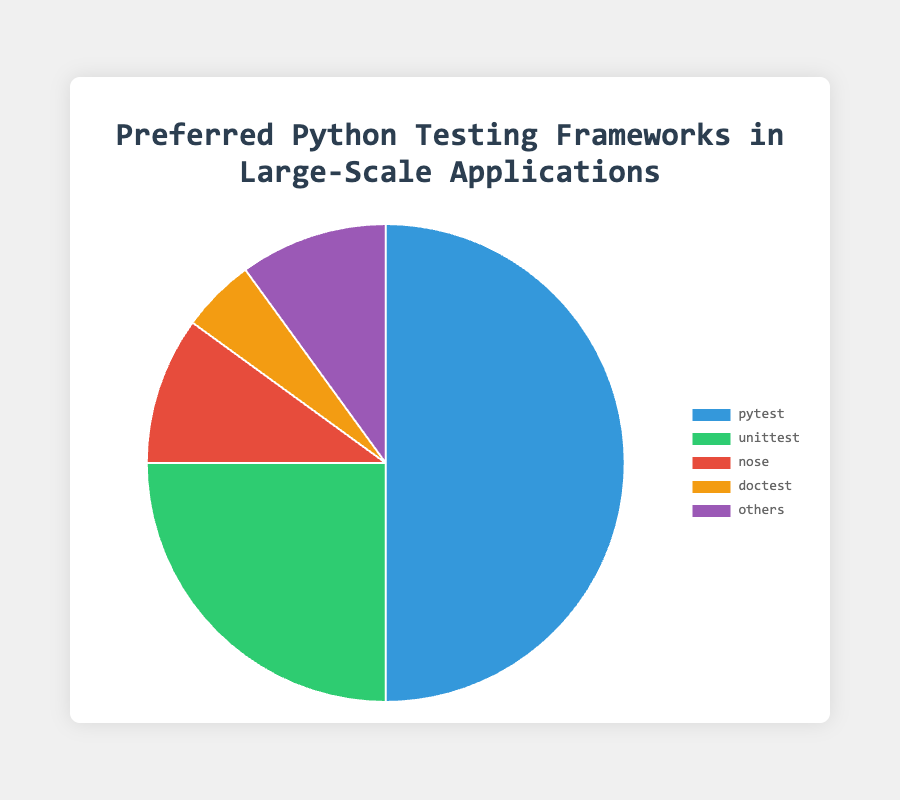Which framework holds the highest preference among large-scale applications? The pie chart shows that `pytest` occupies the largest segment of the chart, indicating it has the highest percentage among the frameworks. Thus, `pytest` is the most preferred.
Answer: pytest What is the combined percentage of frameworks that are not `pytest` or `unittest`? From the chart, the percentages for `nose`, `doctest`, and `others` are 10%, 5%, and 10% respectively. Summing these up, 10% + 5% + 10% = 25%.
Answer: 25% How many frameworks have an equal percentage of preference? By viewing the pie chart, `nose` and `others` both have 10% each. Hence, two frameworks have equal preference.
Answer: 2 How many frameworks hold less than 20% preference each? From the segments represented in the chart, `nose` (10%), `doctest` (5%), and `others` (10%) all have less than 20% each. Thus, there are three.
Answer: 3 Which framework has the smallest slice in the pie chart? Observing the chart, the `doctest` segment is the smallest, representing only 5% of the total.
Answer: doctest Compare the percentages of `nose` and `others`. The pie chart reveals that both `nose` and `others` have the same percentage of 10%. Thus, their preferences are equal.
Answer: Equal What is the percentage difference between `unittest` and `doctest`? The pie chart shows `unittest` at 25% and `doctest` at 5%. The difference is 25% - 5% = 20%.
Answer: 20% Rank the frameworks from highest to lowest preference. According to the pie chart, the order from highest to lowest preference is: `pytest` (50%), `unittest` (25%), `nose` (10%), `others` (10%), and `doctest` (5%).
Answer: pytest, unittest, nose, others, doctest Which framework has the green color in the pie chart? Based on the visual representation in the chart, `unittest` is associated with the green color segment.
Answer: unittest 